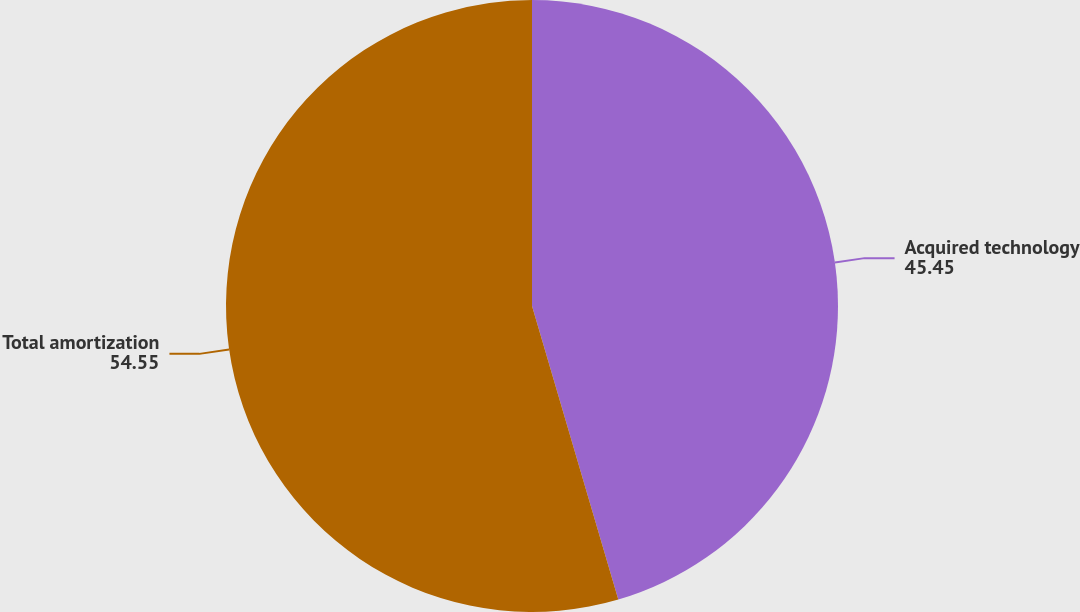Convert chart. <chart><loc_0><loc_0><loc_500><loc_500><pie_chart><fcel>Acquired technology<fcel>Total amortization<nl><fcel>45.45%<fcel>54.55%<nl></chart> 